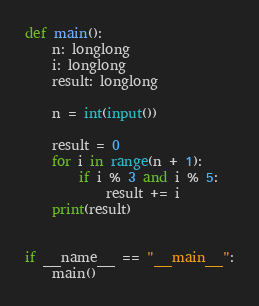Convert code to text. <code><loc_0><loc_0><loc_500><loc_500><_Cython_>def main():
    n: longlong
    i: longlong
    result: longlong

    n = int(input())

    result = 0
    for i in range(n + 1):
        if i % 3 and i % 5:
            result += i
    print(result)


if __name__ == "__main__":
    main()
</code> 